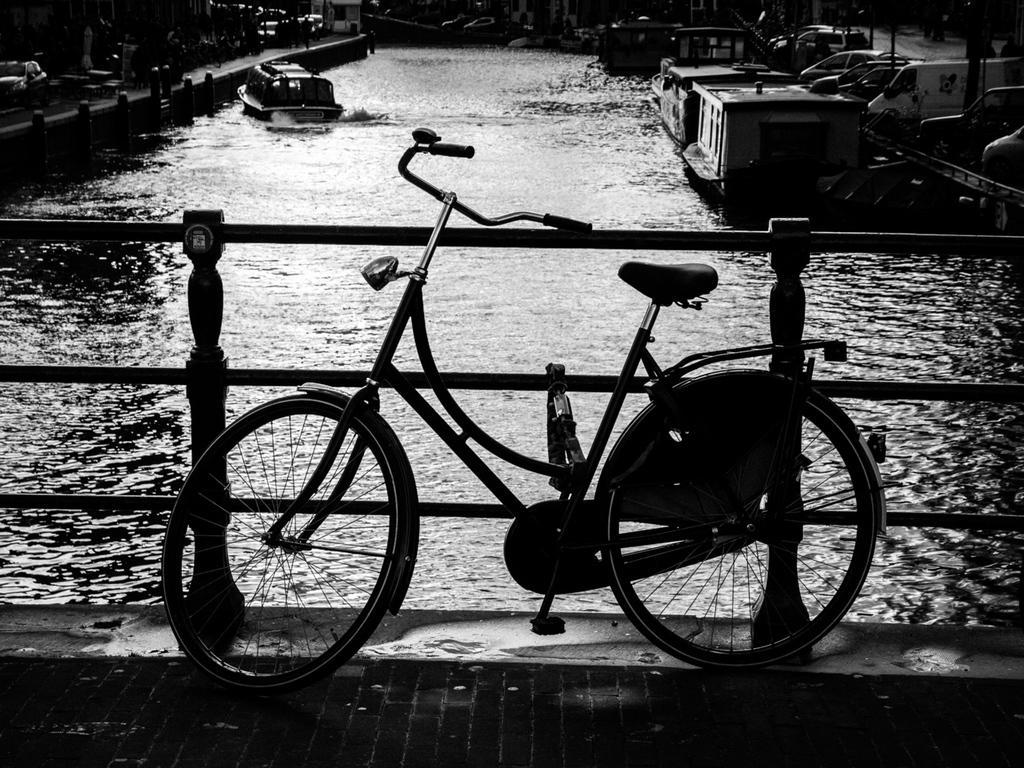Can you describe this image briefly? In this image I can see the bridge, the railing and a bicycle on the bridge. I can see the water, few boats on the surface of the water and few vehicles on both sides of the water. 